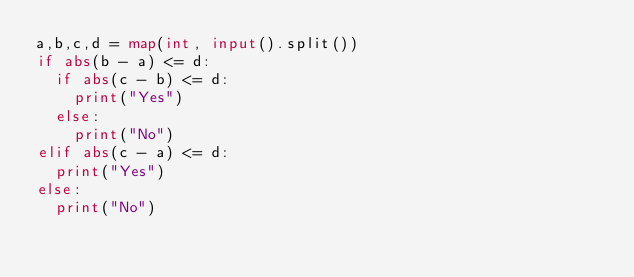Convert code to text. <code><loc_0><loc_0><loc_500><loc_500><_Python_>a,b,c,d = map(int, input().split())
if abs(b - a) <= d:
  if abs(c - b) <= d:
    print("Yes")
  else:
    print("No")
elif abs(c - a) <= d:
  print("Yes")
else:
  print("No")
</code> 